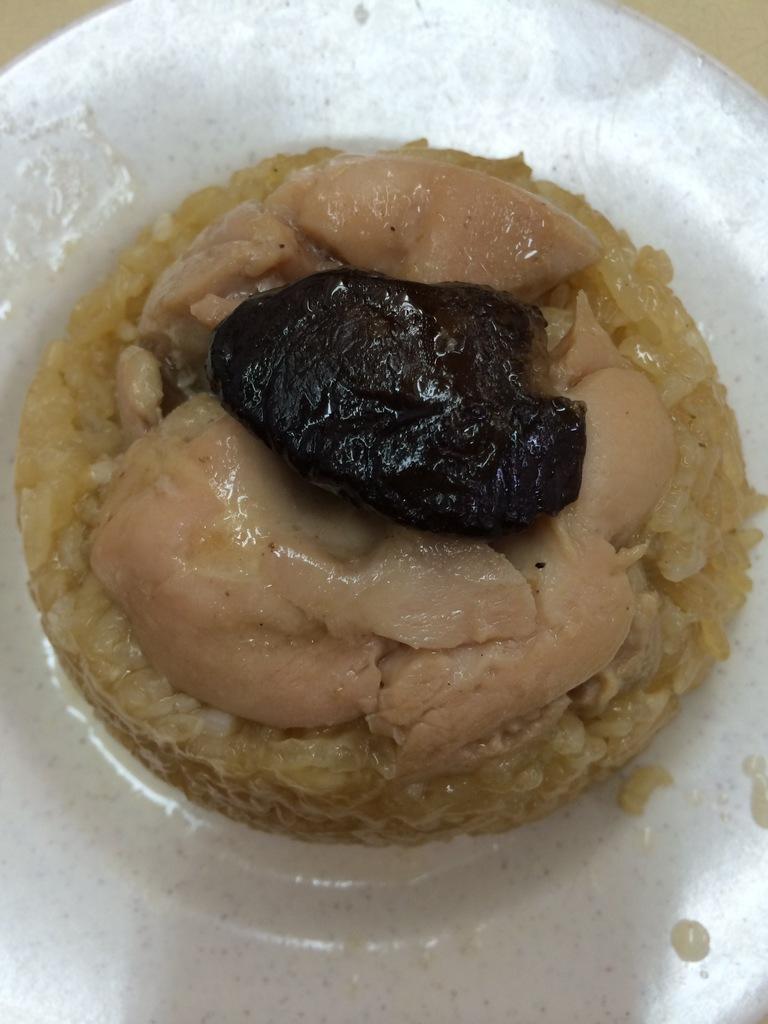How would you summarize this image in a sentence or two? In this image we can see a plate containing food placed on the table. 